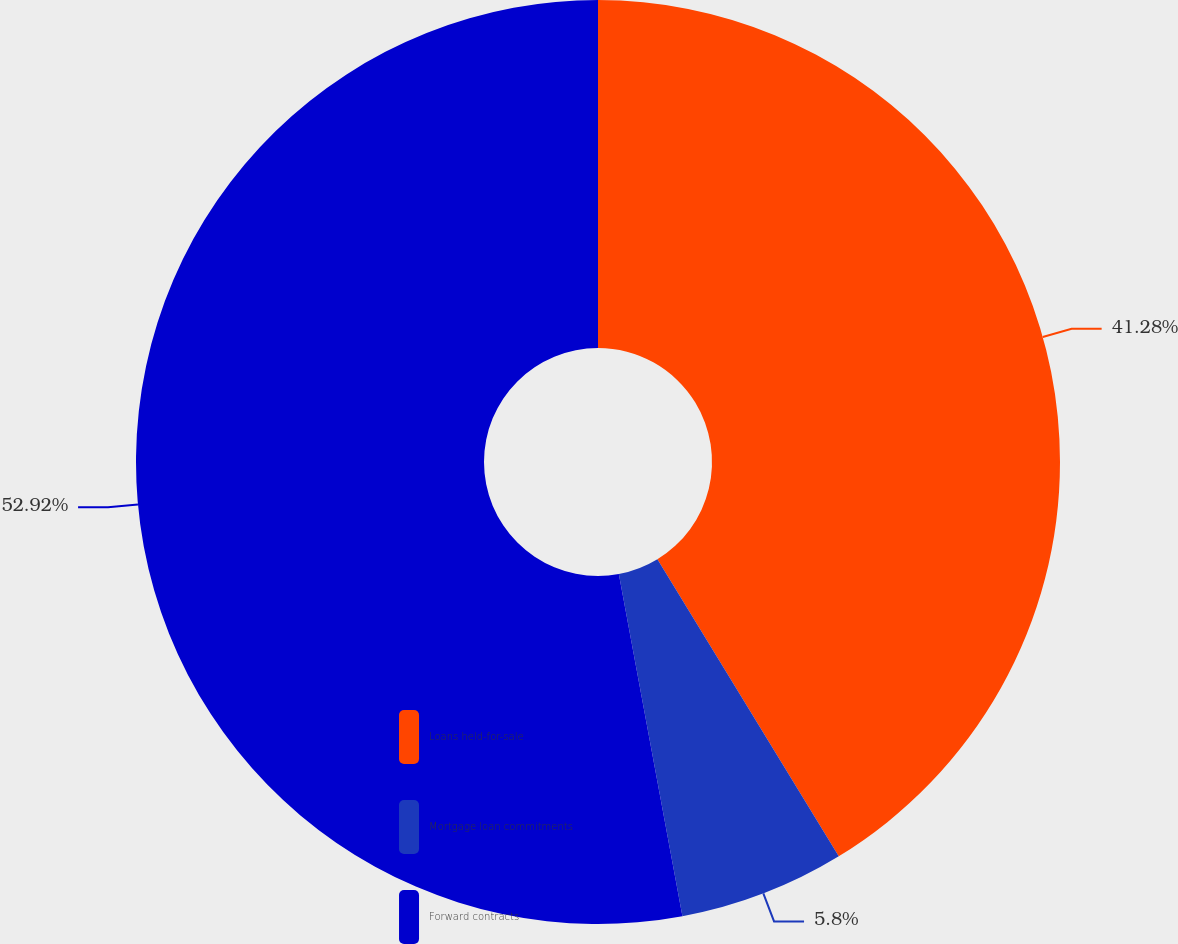Convert chart. <chart><loc_0><loc_0><loc_500><loc_500><pie_chart><fcel>Loans held-for-sale<fcel>Mortgage loan commitments<fcel>Forward contracts<nl><fcel>41.28%<fcel>5.8%<fcel>52.93%<nl></chart> 